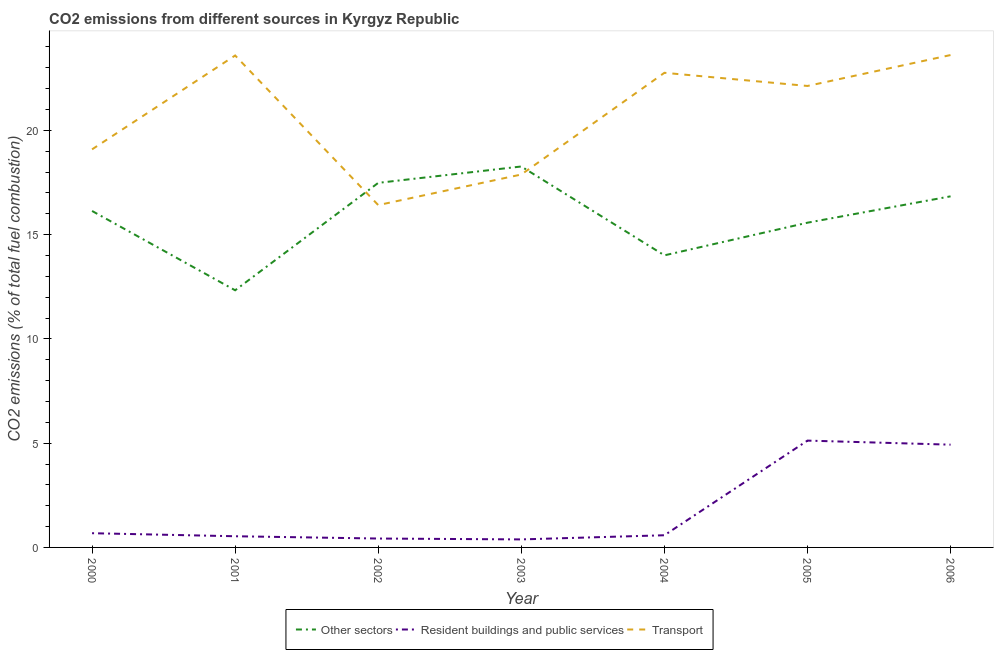What is the percentage of co2 emissions from transport in 2004?
Provide a short and direct response. 22.76. Across all years, what is the maximum percentage of co2 emissions from resident buildings and public services?
Make the answer very short. 5.12. Across all years, what is the minimum percentage of co2 emissions from resident buildings and public services?
Keep it short and to the point. 0.38. In which year was the percentage of co2 emissions from transport minimum?
Make the answer very short. 2002. What is the total percentage of co2 emissions from transport in the graph?
Your answer should be compact. 145.49. What is the difference between the percentage of co2 emissions from resident buildings and public services in 2001 and that in 2004?
Your answer should be very brief. -0.05. What is the difference between the percentage of co2 emissions from other sectors in 2001 and the percentage of co2 emissions from transport in 2002?
Your response must be concise. -4.09. What is the average percentage of co2 emissions from transport per year?
Make the answer very short. 20.78. In the year 2005, what is the difference between the percentage of co2 emissions from other sectors and percentage of co2 emissions from transport?
Ensure brevity in your answer.  -6.56. What is the ratio of the percentage of co2 emissions from resident buildings and public services in 2000 to that in 2001?
Provide a succinct answer. 1.27. What is the difference between the highest and the second highest percentage of co2 emissions from transport?
Give a very brief answer. 0.02. What is the difference between the highest and the lowest percentage of co2 emissions from resident buildings and public services?
Your answer should be very brief. 4.74. In how many years, is the percentage of co2 emissions from other sectors greater than the average percentage of co2 emissions from other sectors taken over all years?
Keep it short and to the point. 4. Does the percentage of co2 emissions from resident buildings and public services monotonically increase over the years?
Your answer should be very brief. No. Is the percentage of co2 emissions from resident buildings and public services strictly greater than the percentage of co2 emissions from other sectors over the years?
Your answer should be compact. No. Is the percentage of co2 emissions from resident buildings and public services strictly less than the percentage of co2 emissions from other sectors over the years?
Your response must be concise. Yes. How many lines are there?
Ensure brevity in your answer.  3. How many years are there in the graph?
Keep it short and to the point. 7. What is the difference between two consecutive major ticks on the Y-axis?
Give a very brief answer. 5. Does the graph contain any zero values?
Make the answer very short. No. Does the graph contain grids?
Ensure brevity in your answer.  No. Where does the legend appear in the graph?
Provide a short and direct response. Bottom center. How many legend labels are there?
Your answer should be very brief. 3. How are the legend labels stacked?
Provide a succinct answer. Horizontal. What is the title of the graph?
Ensure brevity in your answer.  CO2 emissions from different sources in Kyrgyz Republic. Does "Ages 20-60" appear as one of the legend labels in the graph?
Provide a short and direct response. No. What is the label or title of the X-axis?
Keep it short and to the point. Year. What is the label or title of the Y-axis?
Your answer should be very brief. CO2 emissions (% of total fuel combustion). What is the CO2 emissions (% of total fuel combustion) of Other sectors in 2000?
Your answer should be very brief. 16.14. What is the CO2 emissions (% of total fuel combustion) in Resident buildings and public services in 2000?
Make the answer very short. 0.68. What is the CO2 emissions (% of total fuel combustion) in Transport in 2000?
Keep it short and to the point. 19.09. What is the CO2 emissions (% of total fuel combustion) of Other sectors in 2001?
Your answer should be very brief. 12.33. What is the CO2 emissions (% of total fuel combustion) of Resident buildings and public services in 2001?
Make the answer very short. 0.54. What is the CO2 emissions (% of total fuel combustion) in Transport in 2001?
Ensure brevity in your answer.  23.59. What is the CO2 emissions (% of total fuel combustion) of Other sectors in 2002?
Offer a terse response. 17.48. What is the CO2 emissions (% of total fuel combustion) in Resident buildings and public services in 2002?
Keep it short and to the point. 0.43. What is the CO2 emissions (% of total fuel combustion) in Transport in 2002?
Offer a very short reply. 16.42. What is the CO2 emissions (% of total fuel combustion) in Other sectors in 2003?
Your answer should be very brief. 18.27. What is the CO2 emissions (% of total fuel combustion) in Resident buildings and public services in 2003?
Your answer should be very brief. 0.38. What is the CO2 emissions (% of total fuel combustion) of Transport in 2003?
Offer a terse response. 17.88. What is the CO2 emissions (% of total fuel combustion) of Other sectors in 2004?
Offer a very short reply. 14.01. What is the CO2 emissions (% of total fuel combustion) of Resident buildings and public services in 2004?
Make the answer very short. 0.58. What is the CO2 emissions (% of total fuel combustion) in Transport in 2004?
Offer a terse response. 22.76. What is the CO2 emissions (% of total fuel combustion) in Other sectors in 2005?
Offer a terse response. 15.57. What is the CO2 emissions (% of total fuel combustion) of Resident buildings and public services in 2005?
Provide a succinct answer. 5.12. What is the CO2 emissions (% of total fuel combustion) of Transport in 2005?
Your response must be concise. 22.13. What is the CO2 emissions (% of total fuel combustion) in Other sectors in 2006?
Ensure brevity in your answer.  16.84. What is the CO2 emissions (% of total fuel combustion) of Resident buildings and public services in 2006?
Your response must be concise. 4.93. What is the CO2 emissions (% of total fuel combustion) in Transport in 2006?
Keep it short and to the point. 23.61. Across all years, what is the maximum CO2 emissions (% of total fuel combustion) in Other sectors?
Offer a terse response. 18.27. Across all years, what is the maximum CO2 emissions (% of total fuel combustion) of Resident buildings and public services?
Offer a terse response. 5.12. Across all years, what is the maximum CO2 emissions (% of total fuel combustion) in Transport?
Keep it short and to the point. 23.61. Across all years, what is the minimum CO2 emissions (% of total fuel combustion) of Other sectors?
Your answer should be compact. 12.33. Across all years, what is the minimum CO2 emissions (% of total fuel combustion) of Resident buildings and public services?
Your answer should be very brief. 0.38. Across all years, what is the minimum CO2 emissions (% of total fuel combustion) in Transport?
Make the answer very short. 16.42. What is the total CO2 emissions (% of total fuel combustion) of Other sectors in the graph?
Give a very brief answer. 110.64. What is the total CO2 emissions (% of total fuel combustion) in Resident buildings and public services in the graph?
Offer a terse response. 12.66. What is the total CO2 emissions (% of total fuel combustion) in Transport in the graph?
Keep it short and to the point. 145.49. What is the difference between the CO2 emissions (% of total fuel combustion) in Other sectors in 2000 and that in 2001?
Give a very brief answer. 3.8. What is the difference between the CO2 emissions (% of total fuel combustion) of Resident buildings and public services in 2000 and that in 2001?
Keep it short and to the point. 0.15. What is the difference between the CO2 emissions (% of total fuel combustion) in Transport in 2000 and that in 2001?
Provide a short and direct response. -4.5. What is the difference between the CO2 emissions (% of total fuel combustion) in Other sectors in 2000 and that in 2002?
Ensure brevity in your answer.  -1.35. What is the difference between the CO2 emissions (% of total fuel combustion) in Resident buildings and public services in 2000 and that in 2002?
Offer a very short reply. 0.26. What is the difference between the CO2 emissions (% of total fuel combustion) of Transport in 2000 and that in 2002?
Ensure brevity in your answer.  2.67. What is the difference between the CO2 emissions (% of total fuel combustion) in Other sectors in 2000 and that in 2003?
Your answer should be very brief. -2.13. What is the difference between the CO2 emissions (% of total fuel combustion) of Resident buildings and public services in 2000 and that in 2003?
Ensure brevity in your answer.  0.3. What is the difference between the CO2 emissions (% of total fuel combustion) in Transport in 2000 and that in 2003?
Your answer should be very brief. 1.21. What is the difference between the CO2 emissions (% of total fuel combustion) in Other sectors in 2000 and that in 2004?
Provide a short and direct response. 2.13. What is the difference between the CO2 emissions (% of total fuel combustion) of Resident buildings and public services in 2000 and that in 2004?
Give a very brief answer. 0.1. What is the difference between the CO2 emissions (% of total fuel combustion) in Transport in 2000 and that in 2004?
Keep it short and to the point. -3.67. What is the difference between the CO2 emissions (% of total fuel combustion) in Other sectors in 2000 and that in 2005?
Ensure brevity in your answer.  0.56. What is the difference between the CO2 emissions (% of total fuel combustion) of Resident buildings and public services in 2000 and that in 2005?
Your response must be concise. -4.44. What is the difference between the CO2 emissions (% of total fuel combustion) in Transport in 2000 and that in 2005?
Give a very brief answer. -3.04. What is the difference between the CO2 emissions (% of total fuel combustion) in Other sectors in 2000 and that in 2006?
Offer a very short reply. -0.7. What is the difference between the CO2 emissions (% of total fuel combustion) of Resident buildings and public services in 2000 and that in 2006?
Offer a very short reply. -4.25. What is the difference between the CO2 emissions (% of total fuel combustion) in Transport in 2000 and that in 2006?
Provide a short and direct response. -4.52. What is the difference between the CO2 emissions (% of total fuel combustion) in Other sectors in 2001 and that in 2002?
Your response must be concise. -5.15. What is the difference between the CO2 emissions (% of total fuel combustion) in Resident buildings and public services in 2001 and that in 2002?
Your answer should be compact. 0.11. What is the difference between the CO2 emissions (% of total fuel combustion) in Transport in 2001 and that in 2002?
Your response must be concise. 7.17. What is the difference between the CO2 emissions (% of total fuel combustion) in Other sectors in 2001 and that in 2003?
Your answer should be very brief. -5.94. What is the difference between the CO2 emissions (% of total fuel combustion) in Resident buildings and public services in 2001 and that in 2003?
Offer a terse response. 0.15. What is the difference between the CO2 emissions (% of total fuel combustion) of Transport in 2001 and that in 2003?
Give a very brief answer. 5.71. What is the difference between the CO2 emissions (% of total fuel combustion) in Other sectors in 2001 and that in 2004?
Your response must be concise. -1.68. What is the difference between the CO2 emissions (% of total fuel combustion) in Resident buildings and public services in 2001 and that in 2004?
Your response must be concise. -0.05. What is the difference between the CO2 emissions (% of total fuel combustion) in Transport in 2001 and that in 2004?
Provide a short and direct response. 0.83. What is the difference between the CO2 emissions (% of total fuel combustion) in Other sectors in 2001 and that in 2005?
Make the answer very short. -3.24. What is the difference between the CO2 emissions (% of total fuel combustion) in Resident buildings and public services in 2001 and that in 2005?
Give a very brief answer. -4.59. What is the difference between the CO2 emissions (% of total fuel combustion) of Transport in 2001 and that in 2005?
Ensure brevity in your answer.  1.46. What is the difference between the CO2 emissions (% of total fuel combustion) of Other sectors in 2001 and that in 2006?
Give a very brief answer. -4.51. What is the difference between the CO2 emissions (% of total fuel combustion) in Resident buildings and public services in 2001 and that in 2006?
Ensure brevity in your answer.  -4.39. What is the difference between the CO2 emissions (% of total fuel combustion) of Transport in 2001 and that in 2006?
Provide a short and direct response. -0.02. What is the difference between the CO2 emissions (% of total fuel combustion) of Other sectors in 2002 and that in 2003?
Ensure brevity in your answer.  -0.79. What is the difference between the CO2 emissions (% of total fuel combustion) of Resident buildings and public services in 2002 and that in 2003?
Provide a short and direct response. 0.04. What is the difference between the CO2 emissions (% of total fuel combustion) of Transport in 2002 and that in 2003?
Your answer should be very brief. -1.47. What is the difference between the CO2 emissions (% of total fuel combustion) in Other sectors in 2002 and that in 2004?
Your answer should be compact. 3.48. What is the difference between the CO2 emissions (% of total fuel combustion) in Resident buildings and public services in 2002 and that in 2004?
Provide a short and direct response. -0.16. What is the difference between the CO2 emissions (% of total fuel combustion) of Transport in 2002 and that in 2004?
Provide a short and direct response. -6.34. What is the difference between the CO2 emissions (% of total fuel combustion) of Other sectors in 2002 and that in 2005?
Your answer should be very brief. 1.91. What is the difference between the CO2 emissions (% of total fuel combustion) in Resident buildings and public services in 2002 and that in 2005?
Your response must be concise. -4.7. What is the difference between the CO2 emissions (% of total fuel combustion) in Transport in 2002 and that in 2005?
Provide a succinct answer. -5.71. What is the difference between the CO2 emissions (% of total fuel combustion) of Other sectors in 2002 and that in 2006?
Keep it short and to the point. 0.65. What is the difference between the CO2 emissions (% of total fuel combustion) in Resident buildings and public services in 2002 and that in 2006?
Offer a terse response. -4.5. What is the difference between the CO2 emissions (% of total fuel combustion) in Transport in 2002 and that in 2006?
Provide a short and direct response. -7.2. What is the difference between the CO2 emissions (% of total fuel combustion) of Other sectors in 2003 and that in 2004?
Your response must be concise. 4.26. What is the difference between the CO2 emissions (% of total fuel combustion) in Resident buildings and public services in 2003 and that in 2004?
Provide a short and direct response. -0.2. What is the difference between the CO2 emissions (% of total fuel combustion) of Transport in 2003 and that in 2004?
Your answer should be very brief. -4.88. What is the difference between the CO2 emissions (% of total fuel combustion) of Other sectors in 2003 and that in 2005?
Make the answer very short. 2.7. What is the difference between the CO2 emissions (% of total fuel combustion) in Resident buildings and public services in 2003 and that in 2005?
Offer a very short reply. -4.74. What is the difference between the CO2 emissions (% of total fuel combustion) of Transport in 2003 and that in 2005?
Your answer should be compact. -4.25. What is the difference between the CO2 emissions (% of total fuel combustion) in Other sectors in 2003 and that in 2006?
Your answer should be very brief. 1.43. What is the difference between the CO2 emissions (% of total fuel combustion) of Resident buildings and public services in 2003 and that in 2006?
Provide a short and direct response. -4.54. What is the difference between the CO2 emissions (% of total fuel combustion) of Transport in 2003 and that in 2006?
Keep it short and to the point. -5.73. What is the difference between the CO2 emissions (% of total fuel combustion) in Other sectors in 2004 and that in 2005?
Keep it short and to the point. -1.57. What is the difference between the CO2 emissions (% of total fuel combustion) in Resident buildings and public services in 2004 and that in 2005?
Your answer should be compact. -4.54. What is the difference between the CO2 emissions (% of total fuel combustion) of Transport in 2004 and that in 2005?
Provide a short and direct response. 0.63. What is the difference between the CO2 emissions (% of total fuel combustion) of Other sectors in 2004 and that in 2006?
Provide a succinct answer. -2.83. What is the difference between the CO2 emissions (% of total fuel combustion) of Resident buildings and public services in 2004 and that in 2006?
Give a very brief answer. -4.34. What is the difference between the CO2 emissions (% of total fuel combustion) of Transport in 2004 and that in 2006?
Make the answer very short. -0.85. What is the difference between the CO2 emissions (% of total fuel combustion) of Other sectors in 2005 and that in 2006?
Your response must be concise. -1.26. What is the difference between the CO2 emissions (% of total fuel combustion) of Resident buildings and public services in 2005 and that in 2006?
Give a very brief answer. 0.19. What is the difference between the CO2 emissions (% of total fuel combustion) of Transport in 2005 and that in 2006?
Make the answer very short. -1.48. What is the difference between the CO2 emissions (% of total fuel combustion) in Other sectors in 2000 and the CO2 emissions (% of total fuel combustion) in Resident buildings and public services in 2001?
Ensure brevity in your answer.  15.6. What is the difference between the CO2 emissions (% of total fuel combustion) in Other sectors in 2000 and the CO2 emissions (% of total fuel combustion) in Transport in 2001?
Offer a very short reply. -7.46. What is the difference between the CO2 emissions (% of total fuel combustion) of Resident buildings and public services in 2000 and the CO2 emissions (% of total fuel combustion) of Transport in 2001?
Provide a short and direct response. -22.91. What is the difference between the CO2 emissions (% of total fuel combustion) in Other sectors in 2000 and the CO2 emissions (% of total fuel combustion) in Resident buildings and public services in 2002?
Provide a succinct answer. 15.71. What is the difference between the CO2 emissions (% of total fuel combustion) of Other sectors in 2000 and the CO2 emissions (% of total fuel combustion) of Transport in 2002?
Your answer should be very brief. -0.28. What is the difference between the CO2 emissions (% of total fuel combustion) of Resident buildings and public services in 2000 and the CO2 emissions (% of total fuel combustion) of Transport in 2002?
Keep it short and to the point. -15.74. What is the difference between the CO2 emissions (% of total fuel combustion) in Other sectors in 2000 and the CO2 emissions (% of total fuel combustion) in Resident buildings and public services in 2003?
Keep it short and to the point. 15.75. What is the difference between the CO2 emissions (% of total fuel combustion) of Other sectors in 2000 and the CO2 emissions (% of total fuel combustion) of Transport in 2003?
Provide a succinct answer. -1.75. What is the difference between the CO2 emissions (% of total fuel combustion) in Resident buildings and public services in 2000 and the CO2 emissions (% of total fuel combustion) in Transport in 2003?
Make the answer very short. -17.2. What is the difference between the CO2 emissions (% of total fuel combustion) of Other sectors in 2000 and the CO2 emissions (% of total fuel combustion) of Resident buildings and public services in 2004?
Provide a succinct answer. 15.55. What is the difference between the CO2 emissions (% of total fuel combustion) of Other sectors in 2000 and the CO2 emissions (% of total fuel combustion) of Transport in 2004?
Provide a succinct answer. -6.63. What is the difference between the CO2 emissions (% of total fuel combustion) in Resident buildings and public services in 2000 and the CO2 emissions (% of total fuel combustion) in Transport in 2004?
Make the answer very short. -22.08. What is the difference between the CO2 emissions (% of total fuel combustion) of Other sectors in 2000 and the CO2 emissions (% of total fuel combustion) of Resident buildings and public services in 2005?
Offer a terse response. 11.01. What is the difference between the CO2 emissions (% of total fuel combustion) of Other sectors in 2000 and the CO2 emissions (% of total fuel combustion) of Transport in 2005?
Keep it short and to the point. -5.99. What is the difference between the CO2 emissions (% of total fuel combustion) of Resident buildings and public services in 2000 and the CO2 emissions (% of total fuel combustion) of Transport in 2005?
Give a very brief answer. -21.45. What is the difference between the CO2 emissions (% of total fuel combustion) in Other sectors in 2000 and the CO2 emissions (% of total fuel combustion) in Resident buildings and public services in 2006?
Provide a succinct answer. 11.21. What is the difference between the CO2 emissions (% of total fuel combustion) in Other sectors in 2000 and the CO2 emissions (% of total fuel combustion) in Transport in 2006?
Provide a succinct answer. -7.48. What is the difference between the CO2 emissions (% of total fuel combustion) in Resident buildings and public services in 2000 and the CO2 emissions (% of total fuel combustion) in Transport in 2006?
Provide a short and direct response. -22.93. What is the difference between the CO2 emissions (% of total fuel combustion) of Other sectors in 2001 and the CO2 emissions (% of total fuel combustion) of Resident buildings and public services in 2002?
Offer a terse response. 11.91. What is the difference between the CO2 emissions (% of total fuel combustion) in Other sectors in 2001 and the CO2 emissions (% of total fuel combustion) in Transport in 2002?
Your answer should be very brief. -4.09. What is the difference between the CO2 emissions (% of total fuel combustion) of Resident buildings and public services in 2001 and the CO2 emissions (% of total fuel combustion) of Transport in 2002?
Offer a terse response. -15.88. What is the difference between the CO2 emissions (% of total fuel combustion) in Other sectors in 2001 and the CO2 emissions (% of total fuel combustion) in Resident buildings and public services in 2003?
Provide a short and direct response. 11.95. What is the difference between the CO2 emissions (% of total fuel combustion) of Other sectors in 2001 and the CO2 emissions (% of total fuel combustion) of Transport in 2003?
Offer a terse response. -5.55. What is the difference between the CO2 emissions (% of total fuel combustion) of Resident buildings and public services in 2001 and the CO2 emissions (% of total fuel combustion) of Transport in 2003?
Make the answer very short. -17.35. What is the difference between the CO2 emissions (% of total fuel combustion) in Other sectors in 2001 and the CO2 emissions (% of total fuel combustion) in Resident buildings and public services in 2004?
Your response must be concise. 11.75. What is the difference between the CO2 emissions (% of total fuel combustion) in Other sectors in 2001 and the CO2 emissions (% of total fuel combustion) in Transport in 2004?
Provide a succinct answer. -10.43. What is the difference between the CO2 emissions (% of total fuel combustion) of Resident buildings and public services in 2001 and the CO2 emissions (% of total fuel combustion) of Transport in 2004?
Offer a terse response. -22.23. What is the difference between the CO2 emissions (% of total fuel combustion) in Other sectors in 2001 and the CO2 emissions (% of total fuel combustion) in Resident buildings and public services in 2005?
Give a very brief answer. 7.21. What is the difference between the CO2 emissions (% of total fuel combustion) of Other sectors in 2001 and the CO2 emissions (% of total fuel combustion) of Transport in 2005?
Offer a very short reply. -9.8. What is the difference between the CO2 emissions (% of total fuel combustion) of Resident buildings and public services in 2001 and the CO2 emissions (% of total fuel combustion) of Transport in 2005?
Your answer should be compact. -21.59. What is the difference between the CO2 emissions (% of total fuel combustion) of Other sectors in 2001 and the CO2 emissions (% of total fuel combustion) of Resident buildings and public services in 2006?
Keep it short and to the point. 7.4. What is the difference between the CO2 emissions (% of total fuel combustion) of Other sectors in 2001 and the CO2 emissions (% of total fuel combustion) of Transport in 2006?
Provide a succinct answer. -11.28. What is the difference between the CO2 emissions (% of total fuel combustion) in Resident buildings and public services in 2001 and the CO2 emissions (% of total fuel combustion) in Transport in 2006?
Keep it short and to the point. -23.08. What is the difference between the CO2 emissions (% of total fuel combustion) of Other sectors in 2002 and the CO2 emissions (% of total fuel combustion) of Resident buildings and public services in 2003?
Your answer should be compact. 17.1. What is the difference between the CO2 emissions (% of total fuel combustion) in Other sectors in 2002 and the CO2 emissions (% of total fuel combustion) in Transport in 2003?
Make the answer very short. -0.4. What is the difference between the CO2 emissions (% of total fuel combustion) of Resident buildings and public services in 2002 and the CO2 emissions (% of total fuel combustion) of Transport in 2003?
Offer a very short reply. -17.46. What is the difference between the CO2 emissions (% of total fuel combustion) in Other sectors in 2002 and the CO2 emissions (% of total fuel combustion) in Resident buildings and public services in 2004?
Make the answer very short. 16.9. What is the difference between the CO2 emissions (% of total fuel combustion) in Other sectors in 2002 and the CO2 emissions (% of total fuel combustion) in Transport in 2004?
Make the answer very short. -5.28. What is the difference between the CO2 emissions (% of total fuel combustion) of Resident buildings and public services in 2002 and the CO2 emissions (% of total fuel combustion) of Transport in 2004?
Give a very brief answer. -22.34. What is the difference between the CO2 emissions (% of total fuel combustion) of Other sectors in 2002 and the CO2 emissions (% of total fuel combustion) of Resident buildings and public services in 2005?
Offer a very short reply. 12.36. What is the difference between the CO2 emissions (% of total fuel combustion) in Other sectors in 2002 and the CO2 emissions (% of total fuel combustion) in Transport in 2005?
Your answer should be compact. -4.65. What is the difference between the CO2 emissions (% of total fuel combustion) in Resident buildings and public services in 2002 and the CO2 emissions (% of total fuel combustion) in Transport in 2005?
Your answer should be very brief. -21.7. What is the difference between the CO2 emissions (% of total fuel combustion) in Other sectors in 2002 and the CO2 emissions (% of total fuel combustion) in Resident buildings and public services in 2006?
Offer a terse response. 12.56. What is the difference between the CO2 emissions (% of total fuel combustion) of Other sectors in 2002 and the CO2 emissions (% of total fuel combustion) of Transport in 2006?
Provide a succinct answer. -6.13. What is the difference between the CO2 emissions (% of total fuel combustion) of Resident buildings and public services in 2002 and the CO2 emissions (% of total fuel combustion) of Transport in 2006?
Offer a terse response. -23.19. What is the difference between the CO2 emissions (% of total fuel combustion) in Other sectors in 2003 and the CO2 emissions (% of total fuel combustion) in Resident buildings and public services in 2004?
Keep it short and to the point. 17.69. What is the difference between the CO2 emissions (% of total fuel combustion) of Other sectors in 2003 and the CO2 emissions (% of total fuel combustion) of Transport in 2004?
Provide a succinct answer. -4.49. What is the difference between the CO2 emissions (% of total fuel combustion) in Resident buildings and public services in 2003 and the CO2 emissions (% of total fuel combustion) in Transport in 2004?
Give a very brief answer. -22.38. What is the difference between the CO2 emissions (% of total fuel combustion) in Other sectors in 2003 and the CO2 emissions (% of total fuel combustion) in Resident buildings and public services in 2005?
Your response must be concise. 13.15. What is the difference between the CO2 emissions (% of total fuel combustion) of Other sectors in 2003 and the CO2 emissions (% of total fuel combustion) of Transport in 2005?
Make the answer very short. -3.86. What is the difference between the CO2 emissions (% of total fuel combustion) in Resident buildings and public services in 2003 and the CO2 emissions (% of total fuel combustion) in Transport in 2005?
Your answer should be very brief. -21.75. What is the difference between the CO2 emissions (% of total fuel combustion) in Other sectors in 2003 and the CO2 emissions (% of total fuel combustion) in Resident buildings and public services in 2006?
Provide a short and direct response. 13.34. What is the difference between the CO2 emissions (% of total fuel combustion) of Other sectors in 2003 and the CO2 emissions (% of total fuel combustion) of Transport in 2006?
Your answer should be compact. -5.34. What is the difference between the CO2 emissions (% of total fuel combustion) of Resident buildings and public services in 2003 and the CO2 emissions (% of total fuel combustion) of Transport in 2006?
Provide a succinct answer. -23.23. What is the difference between the CO2 emissions (% of total fuel combustion) in Other sectors in 2004 and the CO2 emissions (% of total fuel combustion) in Resident buildings and public services in 2005?
Provide a succinct answer. 8.88. What is the difference between the CO2 emissions (% of total fuel combustion) of Other sectors in 2004 and the CO2 emissions (% of total fuel combustion) of Transport in 2005?
Offer a very short reply. -8.12. What is the difference between the CO2 emissions (% of total fuel combustion) of Resident buildings and public services in 2004 and the CO2 emissions (% of total fuel combustion) of Transport in 2005?
Your response must be concise. -21.55. What is the difference between the CO2 emissions (% of total fuel combustion) of Other sectors in 2004 and the CO2 emissions (% of total fuel combustion) of Resident buildings and public services in 2006?
Make the answer very short. 9.08. What is the difference between the CO2 emissions (% of total fuel combustion) in Other sectors in 2004 and the CO2 emissions (% of total fuel combustion) in Transport in 2006?
Your answer should be very brief. -9.61. What is the difference between the CO2 emissions (% of total fuel combustion) in Resident buildings and public services in 2004 and the CO2 emissions (% of total fuel combustion) in Transport in 2006?
Offer a terse response. -23.03. What is the difference between the CO2 emissions (% of total fuel combustion) in Other sectors in 2005 and the CO2 emissions (% of total fuel combustion) in Resident buildings and public services in 2006?
Your answer should be very brief. 10.65. What is the difference between the CO2 emissions (% of total fuel combustion) in Other sectors in 2005 and the CO2 emissions (% of total fuel combustion) in Transport in 2006?
Offer a very short reply. -8.04. What is the difference between the CO2 emissions (% of total fuel combustion) of Resident buildings and public services in 2005 and the CO2 emissions (% of total fuel combustion) of Transport in 2006?
Make the answer very short. -18.49. What is the average CO2 emissions (% of total fuel combustion) in Other sectors per year?
Provide a succinct answer. 15.81. What is the average CO2 emissions (% of total fuel combustion) in Resident buildings and public services per year?
Provide a succinct answer. 1.81. What is the average CO2 emissions (% of total fuel combustion) in Transport per year?
Offer a very short reply. 20.78. In the year 2000, what is the difference between the CO2 emissions (% of total fuel combustion) of Other sectors and CO2 emissions (% of total fuel combustion) of Resident buildings and public services?
Make the answer very short. 15.45. In the year 2000, what is the difference between the CO2 emissions (% of total fuel combustion) of Other sectors and CO2 emissions (% of total fuel combustion) of Transport?
Offer a terse response. -2.95. In the year 2000, what is the difference between the CO2 emissions (% of total fuel combustion) of Resident buildings and public services and CO2 emissions (% of total fuel combustion) of Transport?
Your answer should be very brief. -18.41. In the year 2001, what is the difference between the CO2 emissions (% of total fuel combustion) of Other sectors and CO2 emissions (% of total fuel combustion) of Resident buildings and public services?
Offer a terse response. 11.8. In the year 2001, what is the difference between the CO2 emissions (% of total fuel combustion) in Other sectors and CO2 emissions (% of total fuel combustion) in Transport?
Keep it short and to the point. -11.26. In the year 2001, what is the difference between the CO2 emissions (% of total fuel combustion) in Resident buildings and public services and CO2 emissions (% of total fuel combustion) in Transport?
Ensure brevity in your answer.  -23.06. In the year 2002, what is the difference between the CO2 emissions (% of total fuel combustion) of Other sectors and CO2 emissions (% of total fuel combustion) of Resident buildings and public services?
Offer a very short reply. 17.06. In the year 2002, what is the difference between the CO2 emissions (% of total fuel combustion) of Other sectors and CO2 emissions (% of total fuel combustion) of Transport?
Offer a terse response. 1.07. In the year 2002, what is the difference between the CO2 emissions (% of total fuel combustion) in Resident buildings and public services and CO2 emissions (% of total fuel combustion) in Transport?
Give a very brief answer. -15.99. In the year 2003, what is the difference between the CO2 emissions (% of total fuel combustion) in Other sectors and CO2 emissions (% of total fuel combustion) in Resident buildings and public services?
Offer a terse response. 17.88. In the year 2003, what is the difference between the CO2 emissions (% of total fuel combustion) in Other sectors and CO2 emissions (% of total fuel combustion) in Transport?
Make the answer very short. 0.38. In the year 2003, what is the difference between the CO2 emissions (% of total fuel combustion) in Resident buildings and public services and CO2 emissions (% of total fuel combustion) in Transport?
Provide a succinct answer. -17.5. In the year 2004, what is the difference between the CO2 emissions (% of total fuel combustion) in Other sectors and CO2 emissions (% of total fuel combustion) in Resident buildings and public services?
Provide a short and direct response. 13.42. In the year 2004, what is the difference between the CO2 emissions (% of total fuel combustion) of Other sectors and CO2 emissions (% of total fuel combustion) of Transport?
Offer a terse response. -8.75. In the year 2004, what is the difference between the CO2 emissions (% of total fuel combustion) of Resident buildings and public services and CO2 emissions (% of total fuel combustion) of Transport?
Ensure brevity in your answer.  -22.18. In the year 2005, what is the difference between the CO2 emissions (% of total fuel combustion) in Other sectors and CO2 emissions (% of total fuel combustion) in Resident buildings and public services?
Your answer should be compact. 10.45. In the year 2005, what is the difference between the CO2 emissions (% of total fuel combustion) in Other sectors and CO2 emissions (% of total fuel combustion) in Transport?
Your answer should be very brief. -6.56. In the year 2005, what is the difference between the CO2 emissions (% of total fuel combustion) in Resident buildings and public services and CO2 emissions (% of total fuel combustion) in Transport?
Give a very brief answer. -17.01. In the year 2006, what is the difference between the CO2 emissions (% of total fuel combustion) of Other sectors and CO2 emissions (% of total fuel combustion) of Resident buildings and public services?
Make the answer very short. 11.91. In the year 2006, what is the difference between the CO2 emissions (% of total fuel combustion) of Other sectors and CO2 emissions (% of total fuel combustion) of Transport?
Keep it short and to the point. -6.78. In the year 2006, what is the difference between the CO2 emissions (% of total fuel combustion) of Resident buildings and public services and CO2 emissions (% of total fuel combustion) of Transport?
Provide a succinct answer. -18.69. What is the ratio of the CO2 emissions (% of total fuel combustion) of Other sectors in 2000 to that in 2001?
Your answer should be very brief. 1.31. What is the ratio of the CO2 emissions (% of total fuel combustion) in Resident buildings and public services in 2000 to that in 2001?
Your answer should be compact. 1.27. What is the ratio of the CO2 emissions (% of total fuel combustion) in Transport in 2000 to that in 2001?
Your answer should be very brief. 0.81. What is the ratio of the CO2 emissions (% of total fuel combustion) in Other sectors in 2000 to that in 2002?
Your answer should be compact. 0.92. What is the ratio of the CO2 emissions (% of total fuel combustion) in Resident buildings and public services in 2000 to that in 2002?
Provide a short and direct response. 1.6. What is the ratio of the CO2 emissions (% of total fuel combustion) of Transport in 2000 to that in 2002?
Provide a succinct answer. 1.16. What is the ratio of the CO2 emissions (% of total fuel combustion) in Other sectors in 2000 to that in 2003?
Your response must be concise. 0.88. What is the ratio of the CO2 emissions (% of total fuel combustion) of Resident buildings and public services in 2000 to that in 2003?
Provide a short and direct response. 1.77. What is the ratio of the CO2 emissions (% of total fuel combustion) of Transport in 2000 to that in 2003?
Keep it short and to the point. 1.07. What is the ratio of the CO2 emissions (% of total fuel combustion) of Other sectors in 2000 to that in 2004?
Offer a very short reply. 1.15. What is the ratio of the CO2 emissions (% of total fuel combustion) in Resident buildings and public services in 2000 to that in 2004?
Provide a short and direct response. 1.17. What is the ratio of the CO2 emissions (% of total fuel combustion) of Transport in 2000 to that in 2004?
Ensure brevity in your answer.  0.84. What is the ratio of the CO2 emissions (% of total fuel combustion) in Other sectors in 2000 to that in 2005?
Make the answer very short. 1.04. What is the ratio of the CO2 emissions (% of total fuel combustion) of Resident buildings and public services in 2000 to that in 2005?
Ensure brevity in your answer.  0.13. What is the ratio of the CO2 emissions (% of total fuel combustion) in Transport in 2000 to that in 2005?
Ensure brevity in your answer.  0.86. What is the ratio of the CO2 emissions (% of total fuel combustion) of Resident buildings and public services in 2000 to that in 2006?
Your response must be concise. 0.14. What is the ratio of the CO2 emissions (% of total fuel combustion) in Transport in 2000 to that in 2006?
Offer a terse response. 0.81. What is the ratio of the CO2 emissions (% of total fuel combustion) in Other sectors in 2001 to that in 2002?
Your answer should be very brief. 0.71. What is the ratio of the CO2 emissions (% of total fuel combustion) of Resident buildings and public services in 2001 to that in 2002?
Provide a short and direct response. 1.26. What is the ratio of the CO2 emissions (% of total fuel combustion) in Transport in 2001 to that in 2002?
Make the answer very short. 1.44. What is the ratio of the CO2 emissions (% of total fuel combustion) of Other sectors in 2001 to that in 2003?
Provide a short and direct response. 0.68. What is the ratio of the CO2 emissions (% of total fuel combustion) in Resident buildings and public services in 2001 to that in 2003?
Your answer should be compact. 1.39. What is the ratio of the CO2 emissions (% of total fuel combustion) of Transport in 2001 to that in 2003?
Ensure brevity in your answer.  1.32. What is the ratio of the CO2 emissions (% of total fuel combustion) in Other sectors in 2001 to that in 2004?
Keep it short and to the point. 0.88. What is the ratio of the CO2 emissions (% of total fuel combustion) of Resident buildings and public services in 2001 to that in 2004?
Offer a very short reply. 0.92. What is the ratio of the CO2 emissions (% of total fuel combustion) in Transport in 2001 to that in 2004?
Your answer should be compact. 1.04. What is the ratio of the CO2 emissions (% of total fuel combustion) in Other sectors in 2001 to that in 2005?
Give a very brief answer. 0.79. What is the ratio of the CO2 emissions (% of total fuel combustion) of Resident buildings and public services in 2001 to that in 2005?
Your response must be concise. 0.1. What is the ratio of the CO2 emissions (% of total fuel combustion) of Transport in 2001 to that in 2005?
Give a very brief answer. 1.07. What is the ratio of the CO2 emissions (% of total fuel combustion) of Other sectors in 2001 to that in 2006?
Your answer should be compact. 0.73. What is the ratio of the CO2 emissions (% of total fuel combustion) in Resident buildings and public services in 2001 to that in 2006?
Your answer should be very brief. 0.11. What is the ratio of the CO2 emissions (% of total fuel combustion) in Other sectors in 2002 to that in 2003?
Your answer should be very brief. 0.96. What is the ratio of the CO2 emissions (% of total fuel combustion) of Resident buildings and public services in 2002 to that in 2003?
Offer a very short reply. 1.11. What is the ratio of the CO2 emissions (% of total fuel combustion) in Transport in 2002 to that in 2003?
Your answer should be compact. 0.92. What is the ratio of the CO2 emissions (% of total fuel combustion) of Other sectors in 2002 to that in 2004?
Offer a terse response. 1.25. What is the ratio of the CO2 emissions (% of total fuel combustion) in Resident buildings and public services in 2002 to that in 2004?
Provide a succinct answer. 0.73. What is the ratio of the CO2 emissions (% of total fuel combustion) in Transport in 2002 to that in 2004?
Your answer should be very brief. 0.72. What is the ratio of the CO2 emissions (% of total fuel combustion) in Other sectors in 2002 to that in 2005?
Your response must be concise. 1.12. What is the ratio of the CO2 emissions (% of total fuel combustion) in Resident buildings and public services in 2002 to that in 2005?
Offer a terse response. 0.08. What is the ratio of the CO2 emissions (% of total fuel combustion) of Transport in 2002 to that in 2005?
Provide a short and direct response. 0.74. What is the ratio of the CO2 emissions (% of total fuel combustion) in Other sectors in 2002 to that in 2006?
Provide a succinct answer. 1.04. What is the ratio of the CO2 emissions (% of total fuel combustion) in Resident buildings and public services in 2002 to that in 2006?
Keep it short and to the point. 0.09. What is the ratio of the CO2 emissions (% of total fuel combustion) of Transport in 2002 to that in 2006?
Offer a very short reply. 0.7. What is the ratio of the CO2 emissions (% of total fuel combustion) of Other sectors in 2003 to that in 2004?
Your answer should be very brief. 1.3. What is the ratio of the CO2 emissions (% of total fuel combustion) in Resident buildings and public services in 2003 to that in 2004?
Make the answer very short. 0.66. What is the ratio of the CO2 emissions (% of total fuel combustion) of Transport in 2003 to that in 2004?
Make the answer very short. 0.79. What is the ratio of the CO2 emissions (% of total fuel combustion) of Other sectors in 2003 to that in 2005?
Offer a terse response. 1.17. What is the ratio of the CO2 emissions (% of total fuel combustion) in Resident buildings and public services in 2003 to that in 2005?
Your answer should be very brief. 0.08. What is the ratio of the CO2 emissions (% of total fuel combustion) in Transport in 2003 to that in 2005?
Your answer should be very brief. 0.81. What is the ratio of the CO2 emissions (% of total fuel combustion) of Other sectors in 2003 to that in 2006?
Make the answer very short. 1.08. What is the ratio of the CO2 emissions (% of total fuel combustion) of Resident buildings and public services in 2003 to that in 2006?
Offer a terse response. 0.08. What is the ratio of the CO2 emissions (% of total fuel combustion) of Transport in 2003 to that in 2006?
Keep it short and to the point. 0.76. What is the ratio of the CO2 emissions (% of total fuel combustion) of Other sectors in 2004 to that in 2005?
Make the answer very short. 0.9. What is the ratio of the CO2 emissions (% of total fuel combustion) of Resident buildings and public services in 2004 to that in 2005?
Your answer should be very brief. 0.11. What is the ratio of the CO2 emissions (% of total fuel combustion) in Transport in 2004 to that in 2005?
Make the answer very short. 1.03. What is the ratio of the CO2 emissions (% of total fuel combustion) of Other sectors in 2004 to that in 2006?
Provide a succinct answer. 0.83. What is the ratio of the CO2 emissions (% of total fuel combustion) in Resident buildings and public services in 2004 to that in 2006?
Make the answer very short. 0.12. What is the ratio of the CO2 emissions (% of total fuel combustion) in Transport in 2004 to that in 2006?
Provide a succinct answer. 0.96. What is the ratio of the CO2 emissions (% of total fuel combustion) in Other sectors in 2005 to that in 2006?
Provide a succinct answer. 0.92. What is the ratio of the CO2 emissions (% of total fuel combustion) of Resident buildings and public services in 2005 to that in 2006?
Ensure brevity in your answer.  1.04. What is the ratio of the CO2 emissions (% of total fuel combustion) of Transport in 2005 to that in 2006?
Give a very brief answer. 0.94. What is the difference between the highest and the second highest CO2 emissions (% of total fuel combustion) in Other sectors?
Give a very brief answer. 0.79. What is the difference between the highest and the second highest CO2 emissions (% of total fuel combustion) of Resident buildings and public services?
Keep it short and to the point. 0.19. What is the difference between the highest and the second highest CO2 emissions (% of total fuel combustion) in Transport?
Ensure brevity in your answer.  0.02. What is the difference between the highest and the lowest CO2 emissions (% of total fuel combustion) of Other sectors?
Offer a very short reply. 5.94. What is the difference between the highest and the lowest CO2 emissions (% of total fuel combustion) of Resident buildings and public services?
Offer a very short reply. 4.74. What is the difference between the highest and the lowest CO2 emissions (% of total fuel combustion) in Transport?
Your answer should be compact. 7.2. 